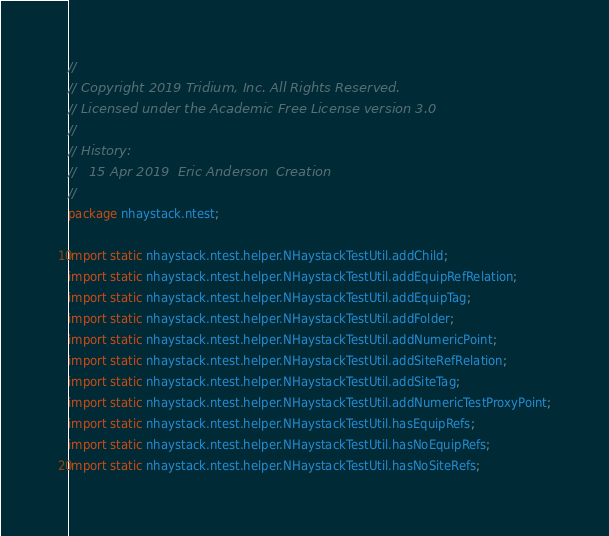Convert code to text. <code><loc_0><loc_0><loc_500><loc_500><_Java_>//
// Copyright 2019 Tridium, Inc. All Rights Reserved.
// Licensed under the Academic Free License version 3.0
//
// History:
//   15 Apr 2019  Eric Anderson  Creation
//
package nhaystack.ntest;

import static nhaystack.ntest.helper.NHaystackTestUtil.addChild;
import static nhaystack.ntest.helper.NHaystackTestUtil.addEquipRefRelation;
import static nhaystack.ntest.helper.NHaystackTestUtil.addEquipTag;
import static nhaystack.ntest.helper.NHaystackTestUtil.addFolder;
import static nhaystack.ntest.helper.NHaystackTestUtil.addNumericPoint;
import static nhaystack.ntest.helper.NHaystackTestUtil.addSiteRefRelation;
import static nhaystack.ntest.helper.NHaystackTestUtil.addSiteTag;
import static nhaystack.ntest.helper.NHaystackTestUtil.addNumericTestProxyPoint;
import static nhaystack.ntest.helper.NHaystackTestUtil.hasEquipRefs;
import static nhaystack.ntest.helper.NHaystackTestUtil.hasNoEquipRefs;
import static nhaystack.ntest.helper.NHaystackTestUtil.hasNoSiteRefs;</code> 